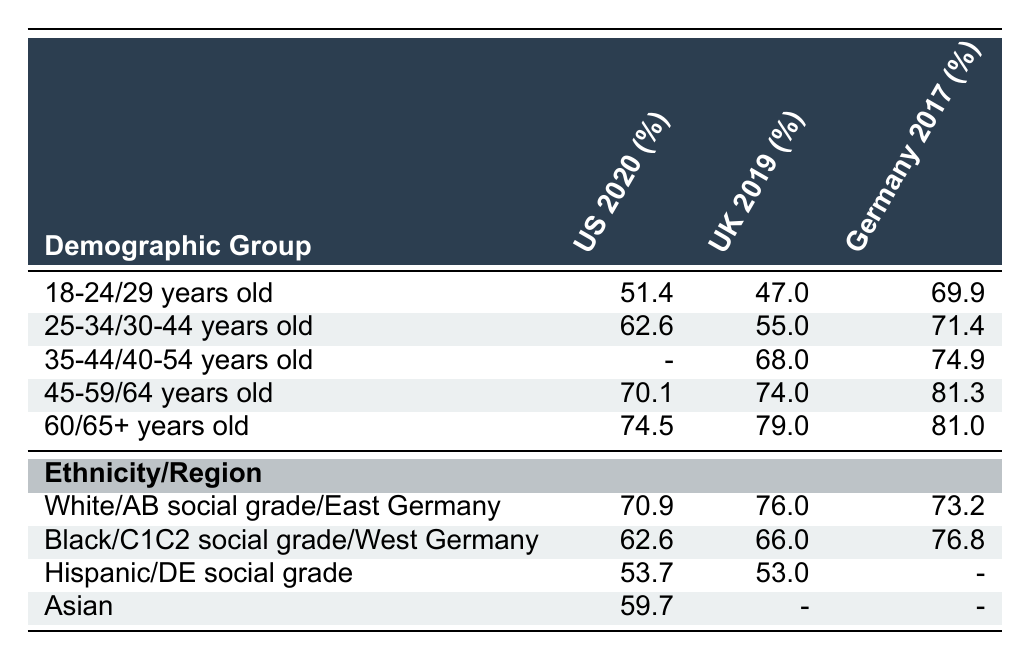What is the voter turnout rate for 45-59/64 years old in the 2017 German Federal Election? According to the table, the voter turnout rate for the 45-59/64 years old demographic group in the 2017 German Federal Election is 81.3 percent.
Answer: 81.3 Which demographic group had the highest voter turnout in the 2020 United States Presidential Election? In the 2020 United States Presidential Election, the demographic group with the highest voter turnout is the 65+ years old group, with a turnout rate of 74.5 percent.
Answer: 65+ years old What is the difference in voter turnout rates between the 18-24 years old group in the UK 2019 election and the 18-29 years old group in the US 2020 election? The turnout rate for the 18-24 years old group in the UK 2019 election is 47 percent, while the 18-29 years old group in the US 2020 election has a rate of 51.4 percent. The difference is 51.4 - 47 = 4.4 percent.
Answer: 4.4 Did the voter turnout for the Black demographic in the US 2020 election exceed 60 percent? The voter turnout for the Black demographic group in the US 2020 election is 62.6 percent, which is greater than 60 percent.
Answer: Yes What is the average voter turnout rate for the 30-44 years old group across all three elections? The 30-44 years old group has turnout rates of 62.6 percent in the US 2020 election, 55.0 percent in the UK 2019 election, and 71.4 percent in the German 2017 election. To find the average, we sum these rates: (62.6 + 55.0 + 71.4) = 189.0. Then we divide by 3: 189.0 / 3 = 63.0 percent.
Answer: 63.0 Which demographic group in the UK 2019 election had a turnout rate lower than the Hispanic group in the US 2020 election? The Hispanic turnout rate in the US 2020 election is 53.7 percent. Looking at the UK 2019 election, the 18-24 years old (47.0) and the DE social grade (53.0) groups had turnout rates lower than 53.7 percent.
Answer: 18-24 years old and DE social grade What is the voter turnout rate for Asians in the US 2020 election? The table shows that the voter turnout rate for the Asian demographic in the US 2020 election is 59.7 percent.
Answer: 59.7 